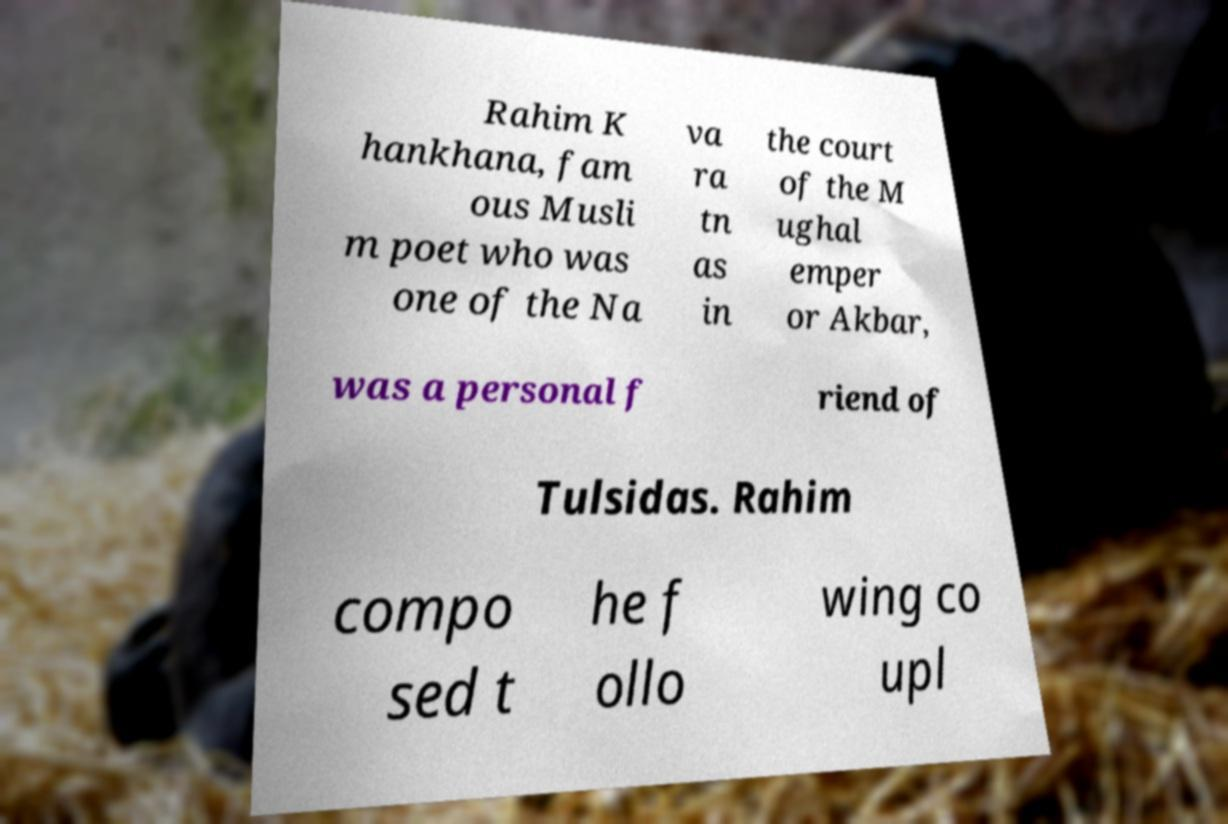I need the written content from this picture converted into text. Can you do that? Rahim K hankhana, fam ous Musli m poet who was one of the Na va ra tn as in the court of the M ughal emper or Akbar, was a personal f riend of Tulsidas. Rahim compo sed t he f ollo wing co upl 